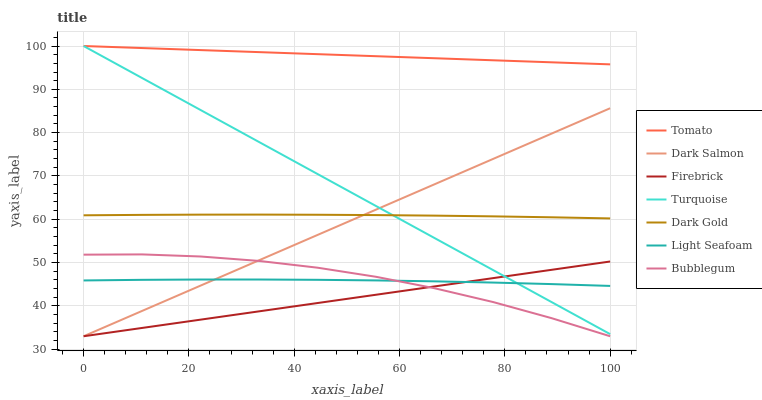Does Firebrick have the minimum area under the curve?
Answer yes or no. Yes. Does Tomato have the maximum area under the curve?
Answer yes or no. Yes. Does Turquoise have the minimum area under the curve?
Answer yes or no. No. Does Turquoise have the maximum area under the curve?
Answer yes or no. No. Is Dark Salmon the smoothest?
Answer yes or no. Yes. Is Bubblegum the roughest?
Answer yes or no. Yes. Is Turquoise the smoothest?
Answer yes or no. No. Is Turquoise the roughest?
Answer yes or no. No. Does Firebrick have the lowest value?
Answer yes or no. Yes. Does Turquoise have the lowest value?
Answer yes or no. No. Does Turquoise have the highest value?
Answer yes or no. Yes. Does Dark Gold have the highest value?
Answer yes or no. No. Is Light Seafoam less than Dark Gold?
Answer yes or no. Yes. Is Dark Gold greater than Firebrick?
Answer yes or no. Yes. Does Firebrick intersect Dark Salmon?
Answer yes or no. Yes. Is Firebrick less than Dark Salmon?
Answer yes or no. No. Is Firebrick greater than Dark Salmon?
Answer yes or no. No. Does Light Seafoam intersect Dark Gold?
Answer yes or no. No. 